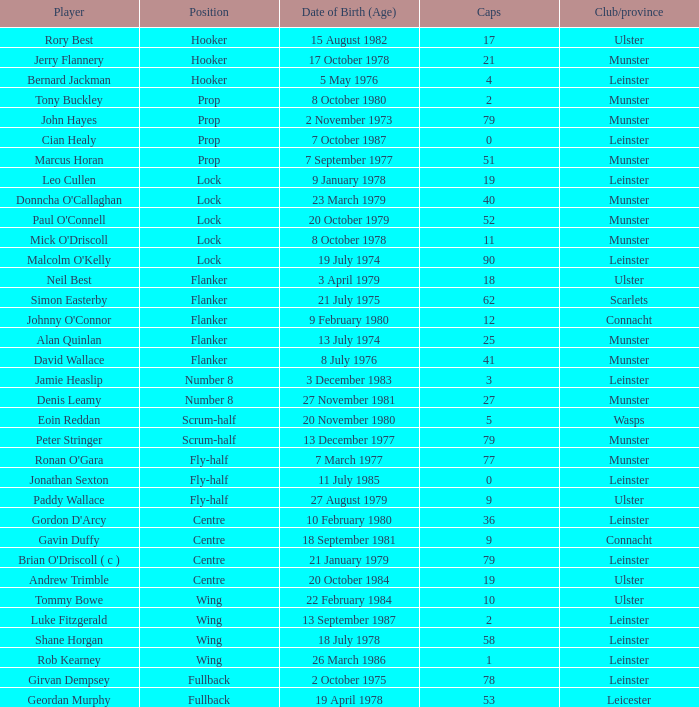What is the total number of caps for a player born on december 13, 1977? 79.0. 